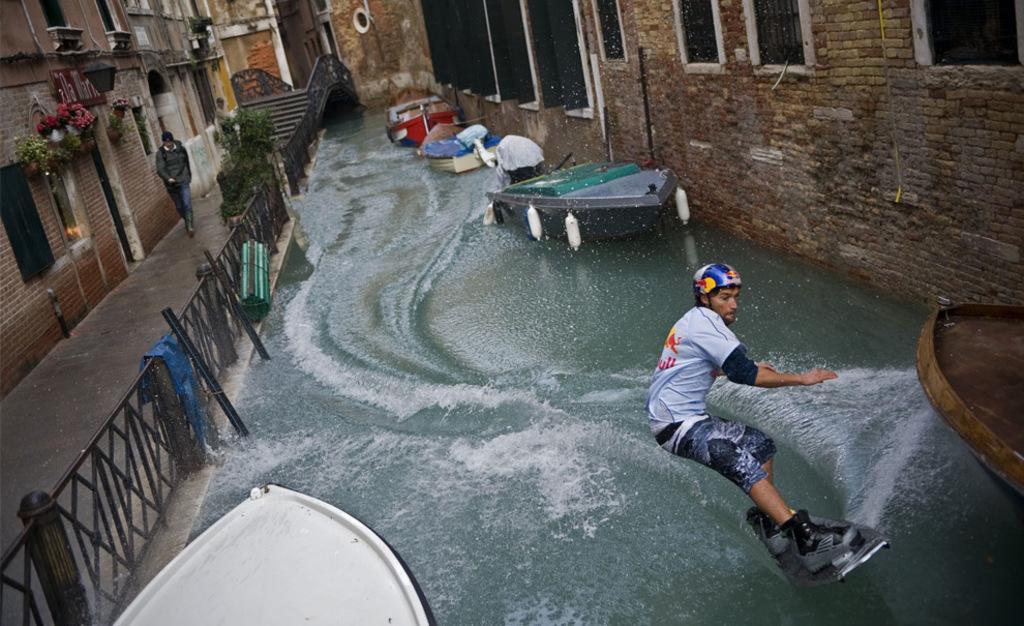How would you summarize this image in a sentence or two? In this image I can see a person surfing on water and on the water I can see boats in the middle and I can see fence, staircase and building and a person walking in front of the building visible in the middle and I can see a flower pots attached to the building on the right side. 